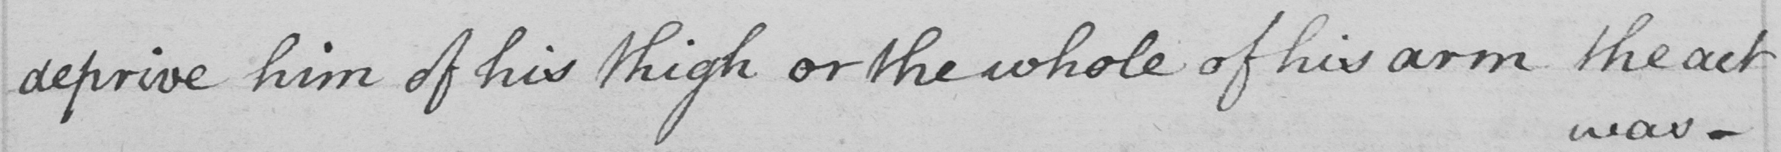Transcribe the text shown in this historical manuscript line. deprive him of his thigh or the whole of his arm the act 